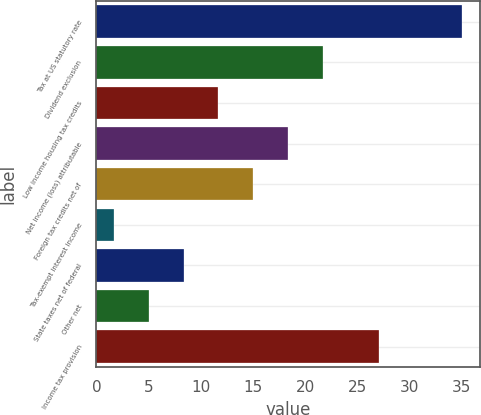Convert chart. <chart><loc_0><loc_0><loc_500><loc_500><bar_chart><fcel>Tax at US statutory rate<fcel>Dividend exclusion<fcel>Low income housing tax credits<fcel>Net income (loss) attributable<fcel>Foreign tax credits net of<fcel>Tax-exempt interest income<fcel>State taxes net of federal<fcel>Other net<fcel>Income tax provision<nl><fcel>35<fcel>21.68<fcel>11.69<fcel>18.35<fcel>15.02<fcel>1.7<fcel>8.36<fcel>5.03<fcel>27.1<nl></chart> 